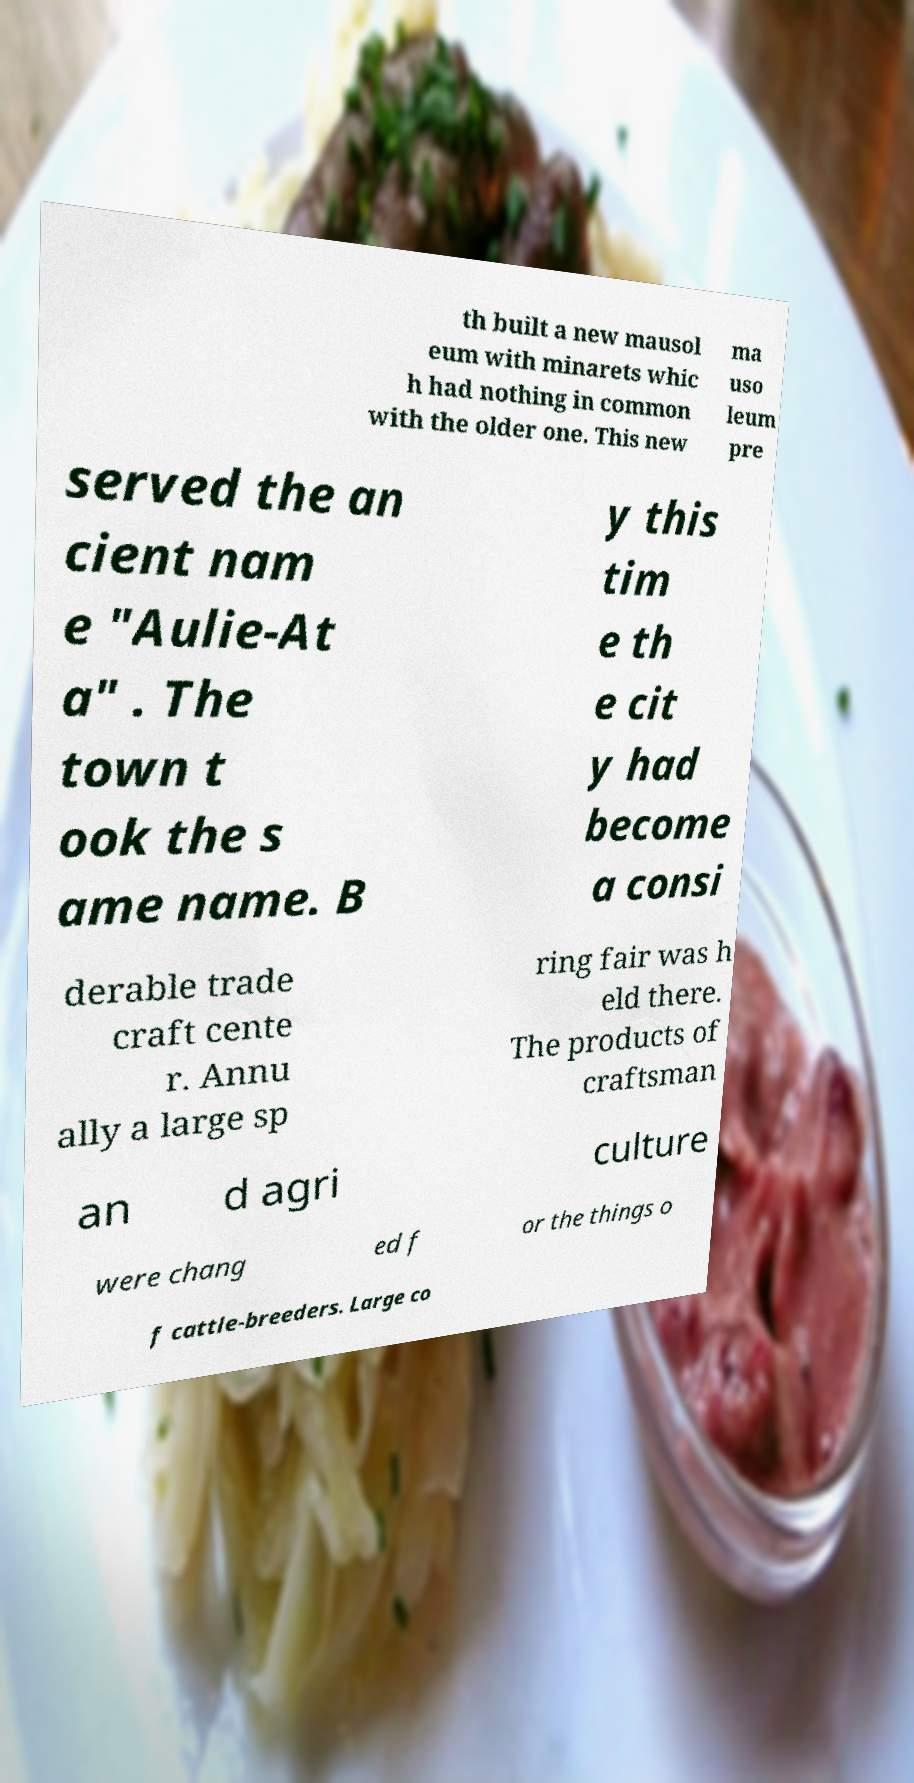Please identify and transcribe the text found in this image. th built a new mausol eum with minarets whic h had nothing in common with the older one. This new ma uso leum pre served the an cient nam e "Aulie-At a" . The town t ook the s ame name. B y this tim e th e cit y had become a consi derable trade craft cente r. Annu ally a large sp ring fair was h eld there. The products of craftsman an d agri culture were chang ed f or the things o f cattle-breeders. Large co 